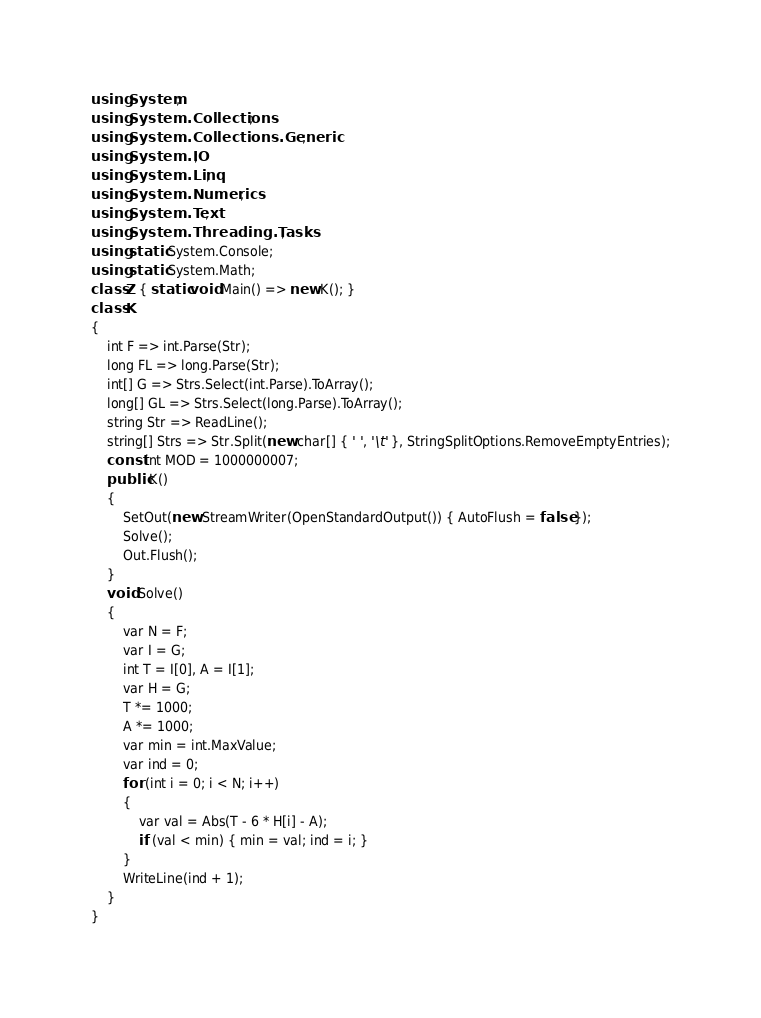<code> <loc_0><loc_0><loc_500><loc_500><_C#_>using System;
using System.Collections;
using System.Collections.Generic;
using System.IO;
using System.Linq;
using System.Numerics;
using System.Text;
using System.Threading.Tasks;
using static System.Console;
using static System.Math;
class Z { static void Main() => new K(); }
class K
{
	int F => int.Parse(Str);
	long FL => long.Parse(Str);
	int[] G => Strs.Select(int.Parse).ToArray();
	long[] GL => Strs.Select(long.Parse).ToArray();
	string Str => ReadLine();
	string[] Strs => Str.Split(new char[] { ' ', '\t' }, StringSplitOptions.RemoveEmptyEntries);
	const int MOD = 1000000007;
	public K()
	{
		SetOut(new StreamWriter(OpenStandardOutput()) { AutoFlush = false });
		Solve();
		Out.Flush();
	}
	void Solve()
	{
		var N = F;
		var I = G;
		int T = I[0], A = I[1];
		var H = G;
		T *= 1000;
		A *= 1000;
		var min = int.MaxValue;
		var ind = 0;
		for (int i = 0; i < N; i++)
		{
			var val = Abs(T - 6 * H[i] - A);
			if (val < min) { min = val; ind = i; }
		}
		WriteLine(ind + 1);
	}
}
</code> 